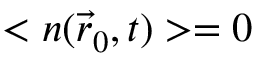<formula> <loc_0><loc_0><loc_500><loc_500>< n ( \vec { r } _ { 0 } , t ) > = 0</formula> 